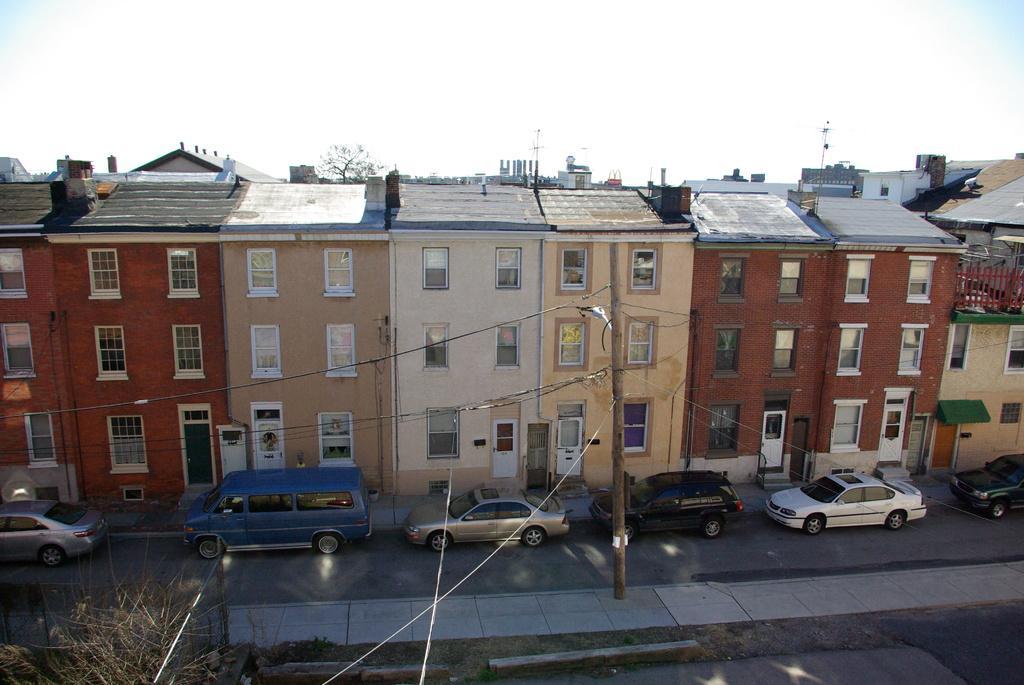Could you give a brief overview of what you see in this image? This image consists of many buildings along with door and windows. At the bottom, there are cars parked on the road. And we can see a plant. At the top, there are clouds in the sky. 